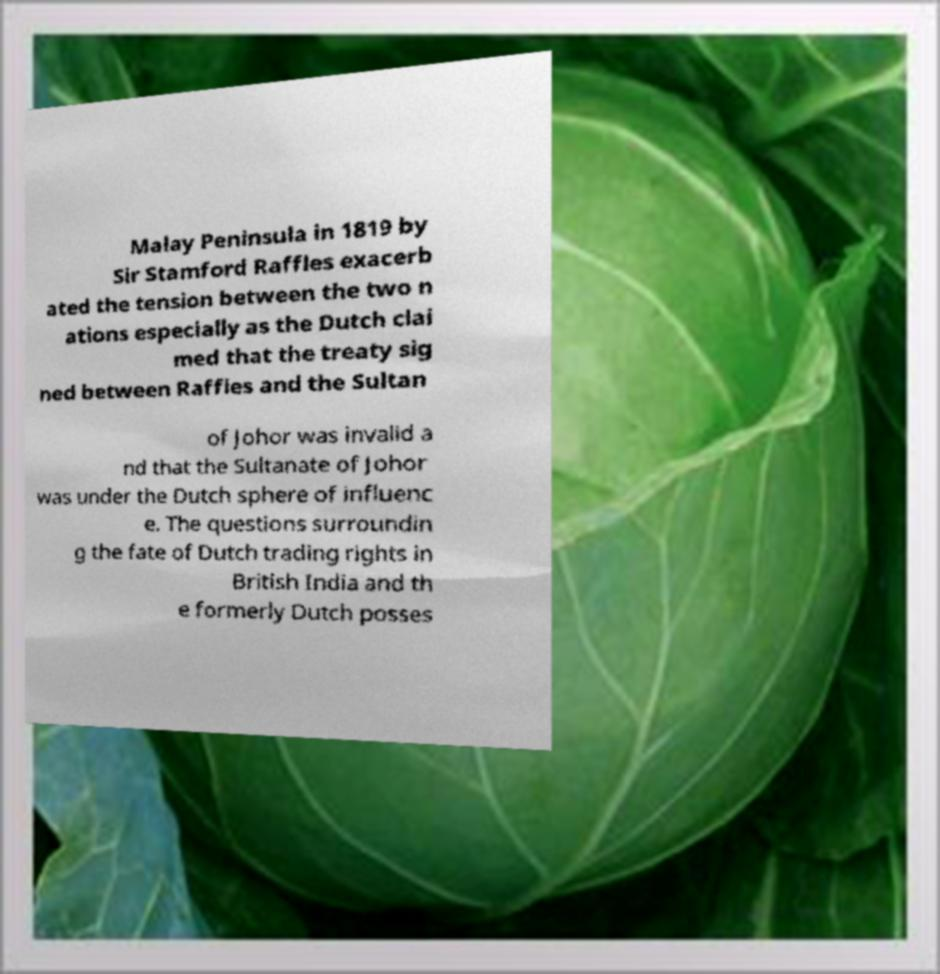Please read and relay the text visible in this image. What does it say? Malay Peninsula in 1819 by Sir Stamford Raffles exacerb ated the tension between the two n ations especially as the Dutch clai med that the treaty sig ned between Raffles and the Sultan of Johor was invalid a nd that the Sultanate of Johor was under the Dutch sphere of influenc e. The questions surroundin g the fate of Dutch trading rights in British India and th e formerly Dutch posses 